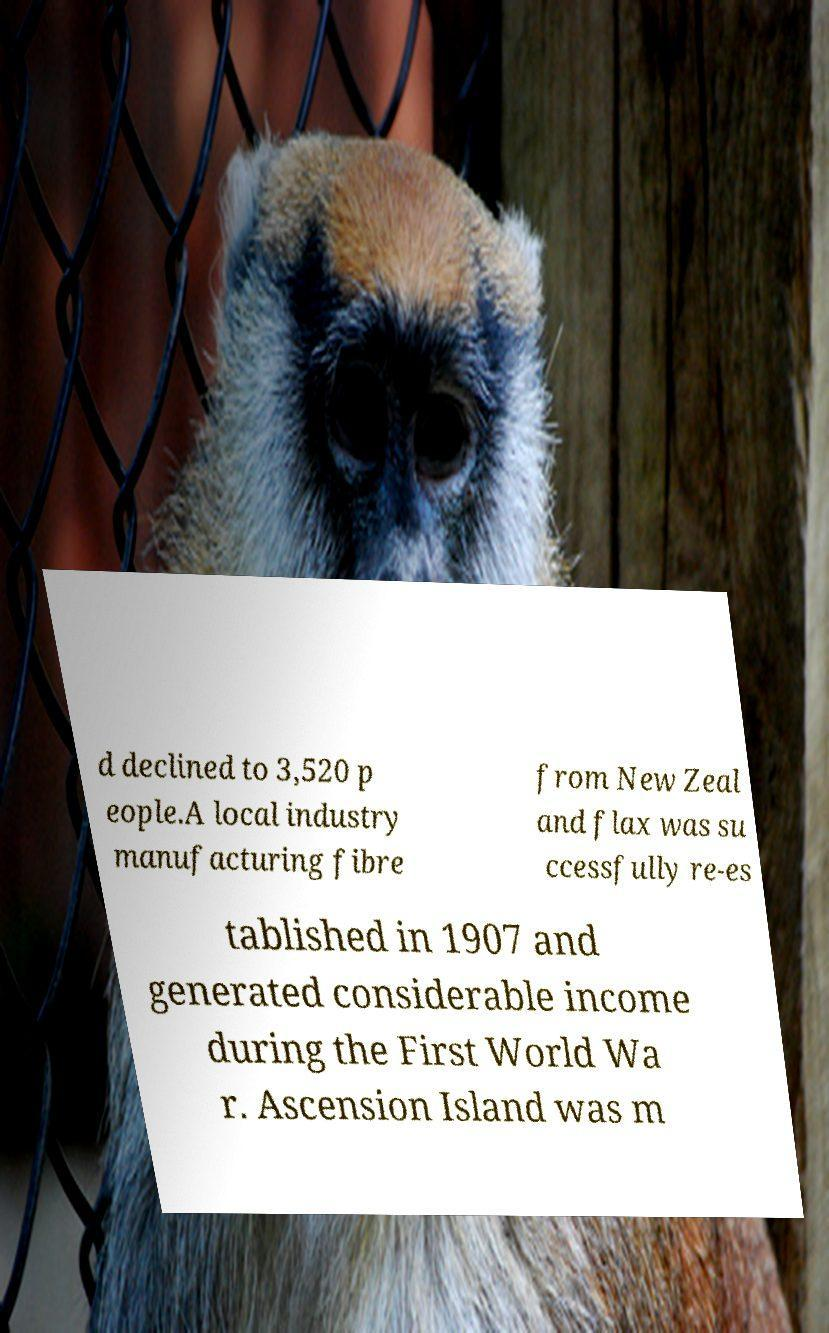What messages or text are displayed in this image? I need them in a readable, typed format. d declined to 3,520 p eople.A local industry manufacturing fibre from New Zeal and flax was su ccessfully re-es tablished in 1907 and generated considerable income during the First World Wa r. Ascension Island was m 